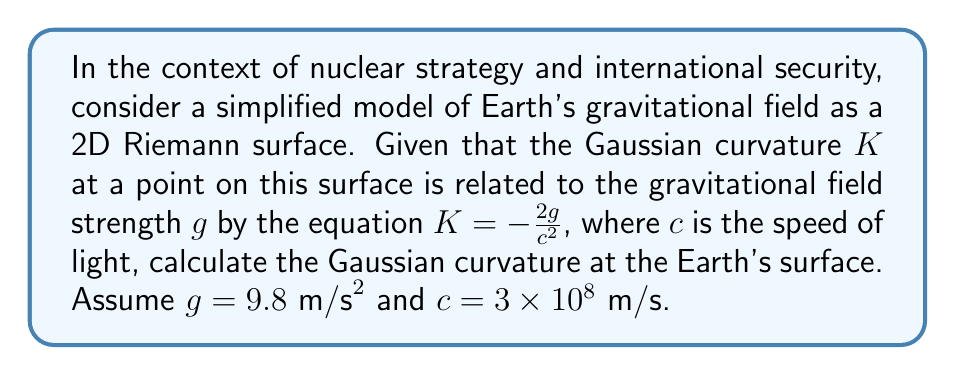Could you help me with this problem? To solve this problem, we'll follow these steps:

1) We are given the equation relating Gaussian curvature $K$ to gravitational field strength $g$:

   $$K = -\frac{2g}{c^2}$$

2) We're also given the values:
   $g = 9.8 \text{ m/s}^2$
   $c = 3 \times 10^8 \text{ m/s}$

3) Let's substitute these values into the equation:

   $$K = -\frac{2(9.8)}{(3 \times 10^8)^2}$$

4) Simplify the numerator:

   $$K = -\frac{19.6}{(3 \times 10^8)^2}$$

5) Calculate the denominator:

   $$K = -\frac{19.6}{9 \times 10^{16}}$$

6) Divide:

   $$K = -2.18 \times 10^{-17} \text{ m}^{-2}$$

The negative sign indicates that the curvature is in the opposite direction of the gravitational field, which is consistent with the warping of spacetime described by General Relativity.
Answer: $-2.18 \times 10^{-17} \text{ m}^{-2}$ 